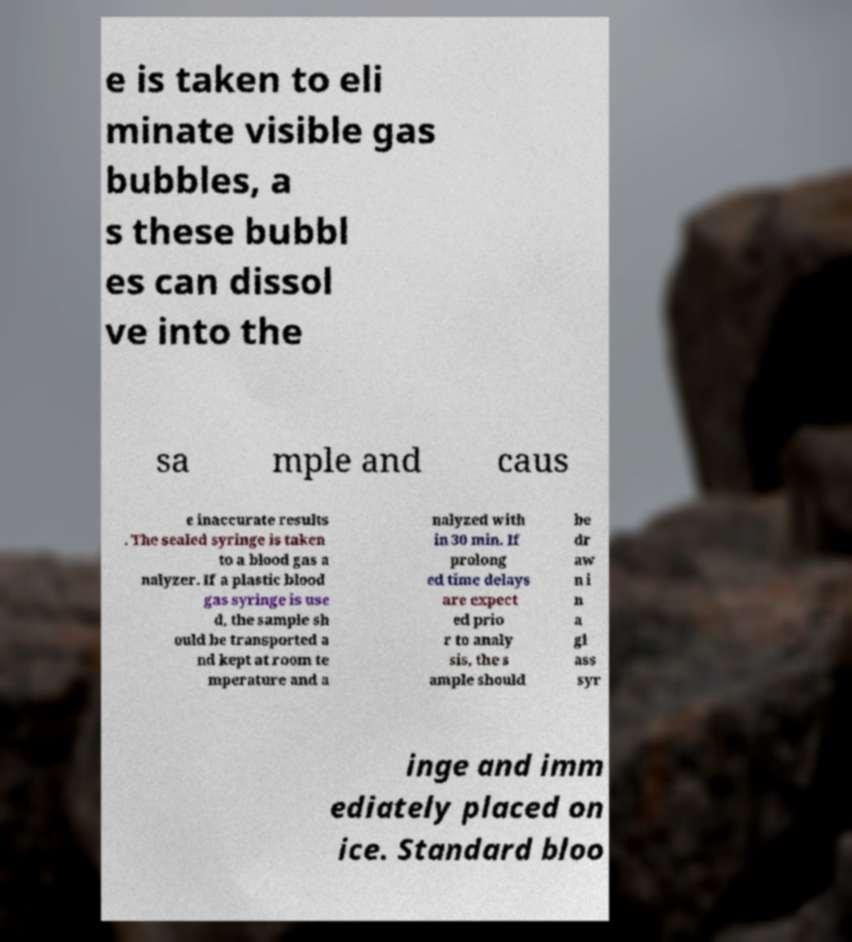Could you assist in decoding the text presented in this image and type it out clearly? e is taken to eli minate visible gas bubbles, a s these bubbl es can dissol ve into the sa mple and caus e inaccurate results . The sealed syringe is taken to a blood gas a nalyzer. If a plastic blood gas syringe is use d, the sample sh ould be transported a nd kept at room te mperature and a nalyzed with in 30 min. If prolong ed time delays are expect ed prio r to analy sis, the s ample should be dr aw n i n a gl ass syr inge and imm ediately placed on ice. Standard bloo 